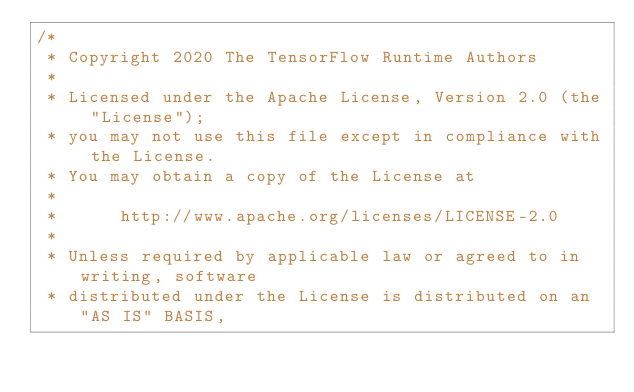Convert code to text. <code><loc_0><loc_0><loc_500><loc_500><_C++_>/*
 * Copyright 2020 The TensorFlow Runtime Authors
 *
 * Licensed under the Apache License, Version 2.0 (the "License");
 * you may not use this file except in compliance with the License.
 * You may obtain a copy of the License at
 *
 *      http://www.apache.org/licenses/LICENSE-2.0
 *
 * Unless required by applicable law or agreed to in writing, software
 * distributed under the License is distributed on an "AS IS" BASIS,</code> 